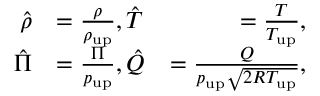<formula> <loc_0><loc_0><loc_500><loc_500>\begin{array} { r l r } { \hat { \rho } } & { = \frac { \rho } { \rho _ { u p } } , \hat { T } } & { = \frac { T } { T _ { u p } } , } \\ { \hat { \Pi } } & { = \frac { \Pi } { p _ { u p } } , \hat { Q } } & { = \frac { Q } { p _ { u p } \sqrt { 2 R T _ { u p } } } , } \end{array}</formula> 